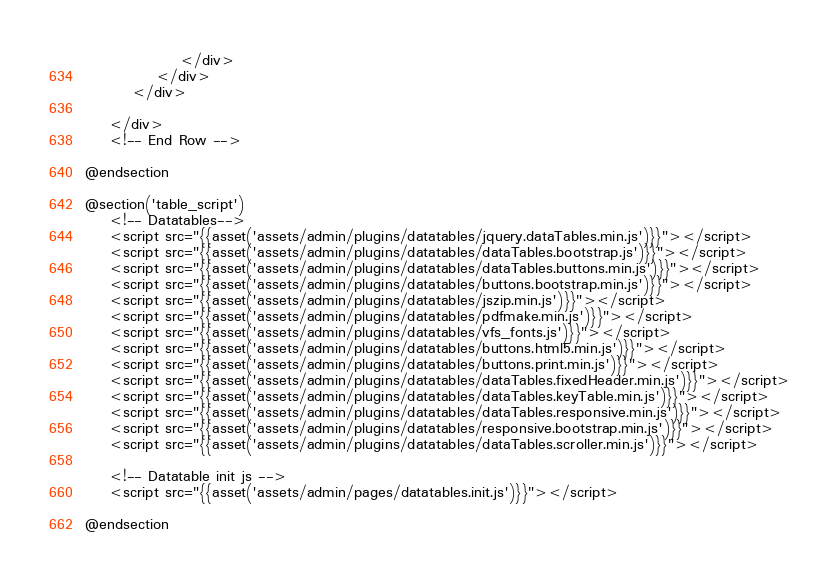Convert code to text. <code><loc_0><loc_0><loc_500><loc_500><_PHP_>
                </div>
            </div>
        </div>

    </div>
    <!-- End Row -->

@endsection

@section('table_script')
    <!-- Datatables-->
    <script src="{{asset('assets/admin/plugins/datatables/jquery.dataTables.min.js')}}"></script>
    <script src="{{asset('assets/admin/plugins/datatables/dataTables.bootstrap.js')}}"></script>
    <script src="{{asset('assets/admin/plugins/datatables/dataTables.buttons.min.js')}}"></script>
    <script src="{{asset('assets/admin/plugins/datatables/buttons.bootstrap.min.js')}}"></script>
    <script src="{{asset('assets/admin/plugins/datatables/jszip.min.js')}}"></script>
    <script src="{{asset('assets/admin/plugins/datatables/pdfmake.min.js')}}"></script>
    <script src="{{asset('assets/admin/plugins/datatables/vfs_fonts.js')}}"></script>
    <script src="{{asset('assets/admin/plugins/datatables/buttons.html5.min.js')}}"></script>
    <script src="{{asset('assets/admin/plugins/datatables/buttons.print.min.js')}}"></script>
    <script src="{{asset('assets/admin/plugins/datatables/dataTables.fixedHeader.min.js')}}"></script>
    <script src="{{asset('assets/admin/plugins/datatables/dataTables.keyTable.min.js')}}"></script>
    <script src="{{asset('assets/admin/plugins/datatables/dataTables.responsive.min.js')}}"></script>
    <script src="{{asset('assets/admin/plugins/datatables/responsive.bootstrap.min.js')}}"></script>
    <script src="{{asset('assets/admin/plugins/datatables/dataTables.scroller.min.js')}}"></script>

    <!-- Datatable init js -->
    <script src="{{asset('assets/admin/pages/datatables.init.js')}}"></script>

@endsection
</code> 